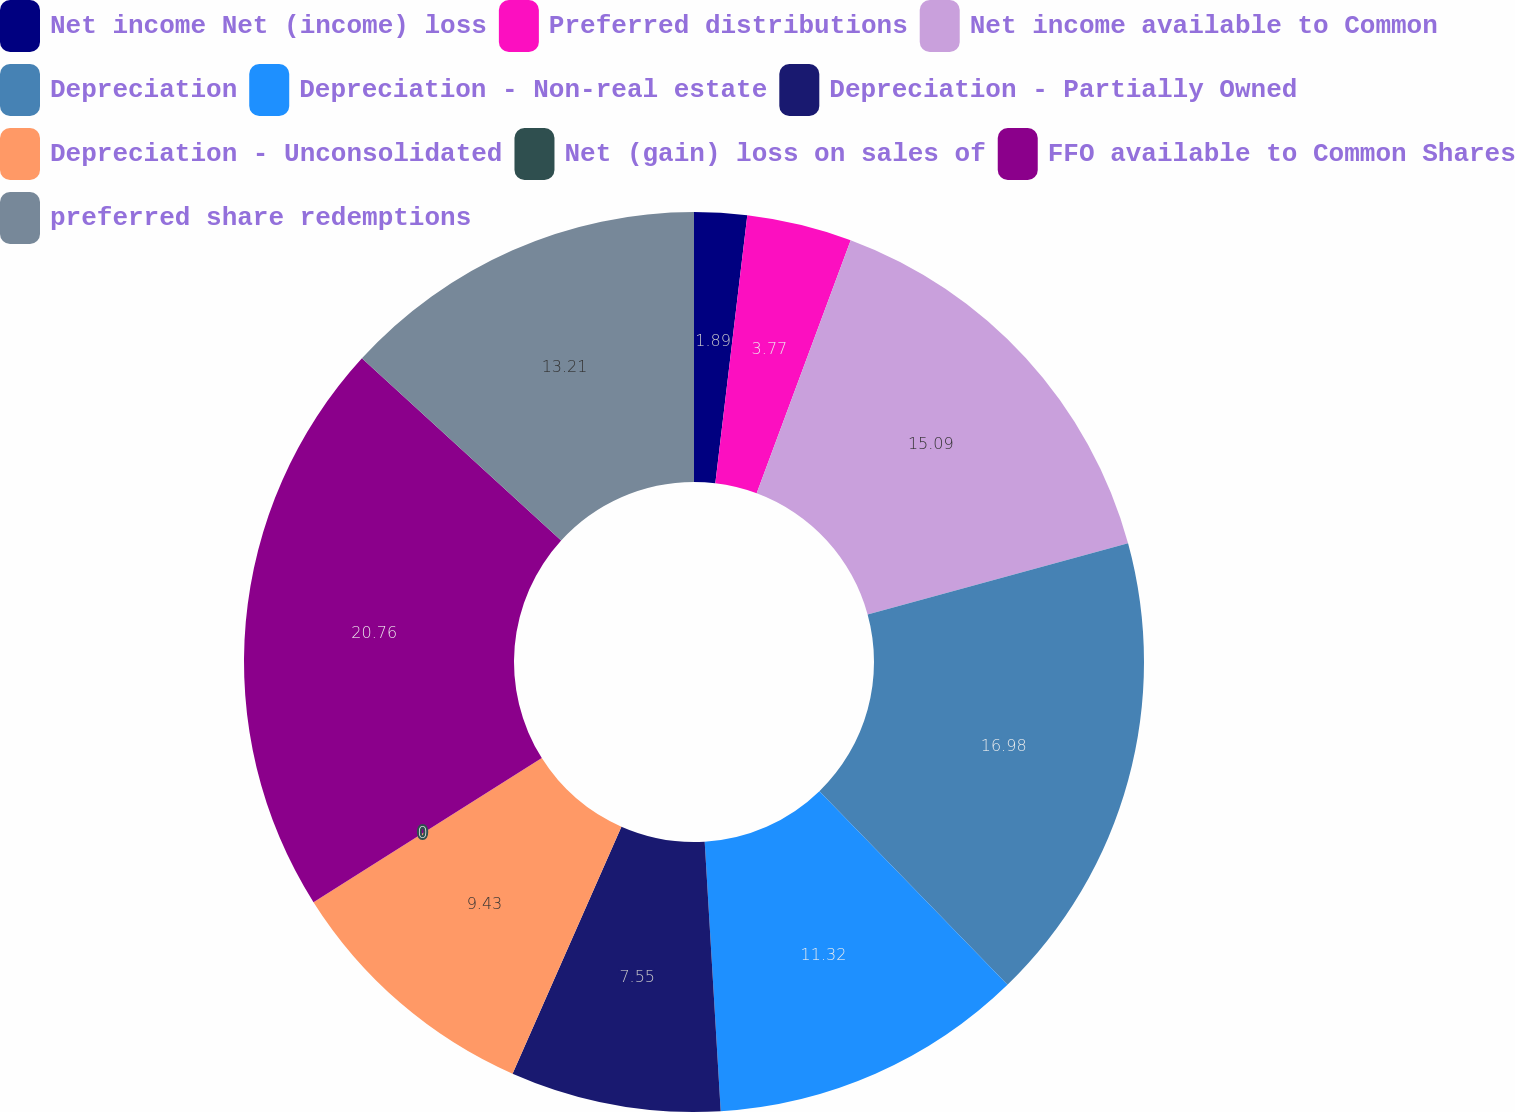Convert chart. <chart><loc_0><loc_0><loc_500><loc_500><pie_chart><fcel>Net income Net (income) loss<fcel>Preferred distributions<fcel>Net income available to Common<fcel>Depreciation<fcel>Depreciation - Non-real estate<fcel>Depreciation - Partially Owned<fcel>Depreciation - Unconsolidated<fcel>Net (gain) loss on sales of<fcel>FFO available to Common Shares<fcel>preferred share redemptions<nl><fcel>1.89%<fcel>3.77%<fcel>15.09%<fcel>16.98%<fcel>11.32%<fcel>7.55%<fcel>9.43%<fcel>0.0%<fcel>20.75%<fcel>13.21%<nl></chart> 